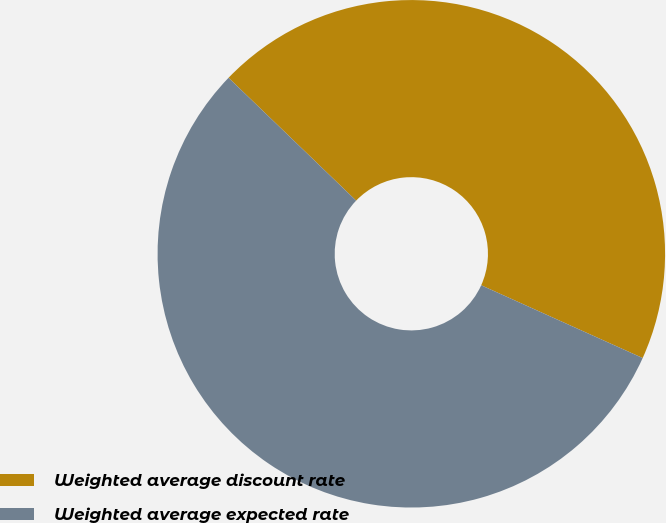Convert chart. <chart><loc_0><loc_0><loc_500><loc_500><pie_chart><fcel>Weighted average discount rate<fcel>Weighted average expected rate<nl><fcel>44.54%<fcel>55.46%<nl></chart> 